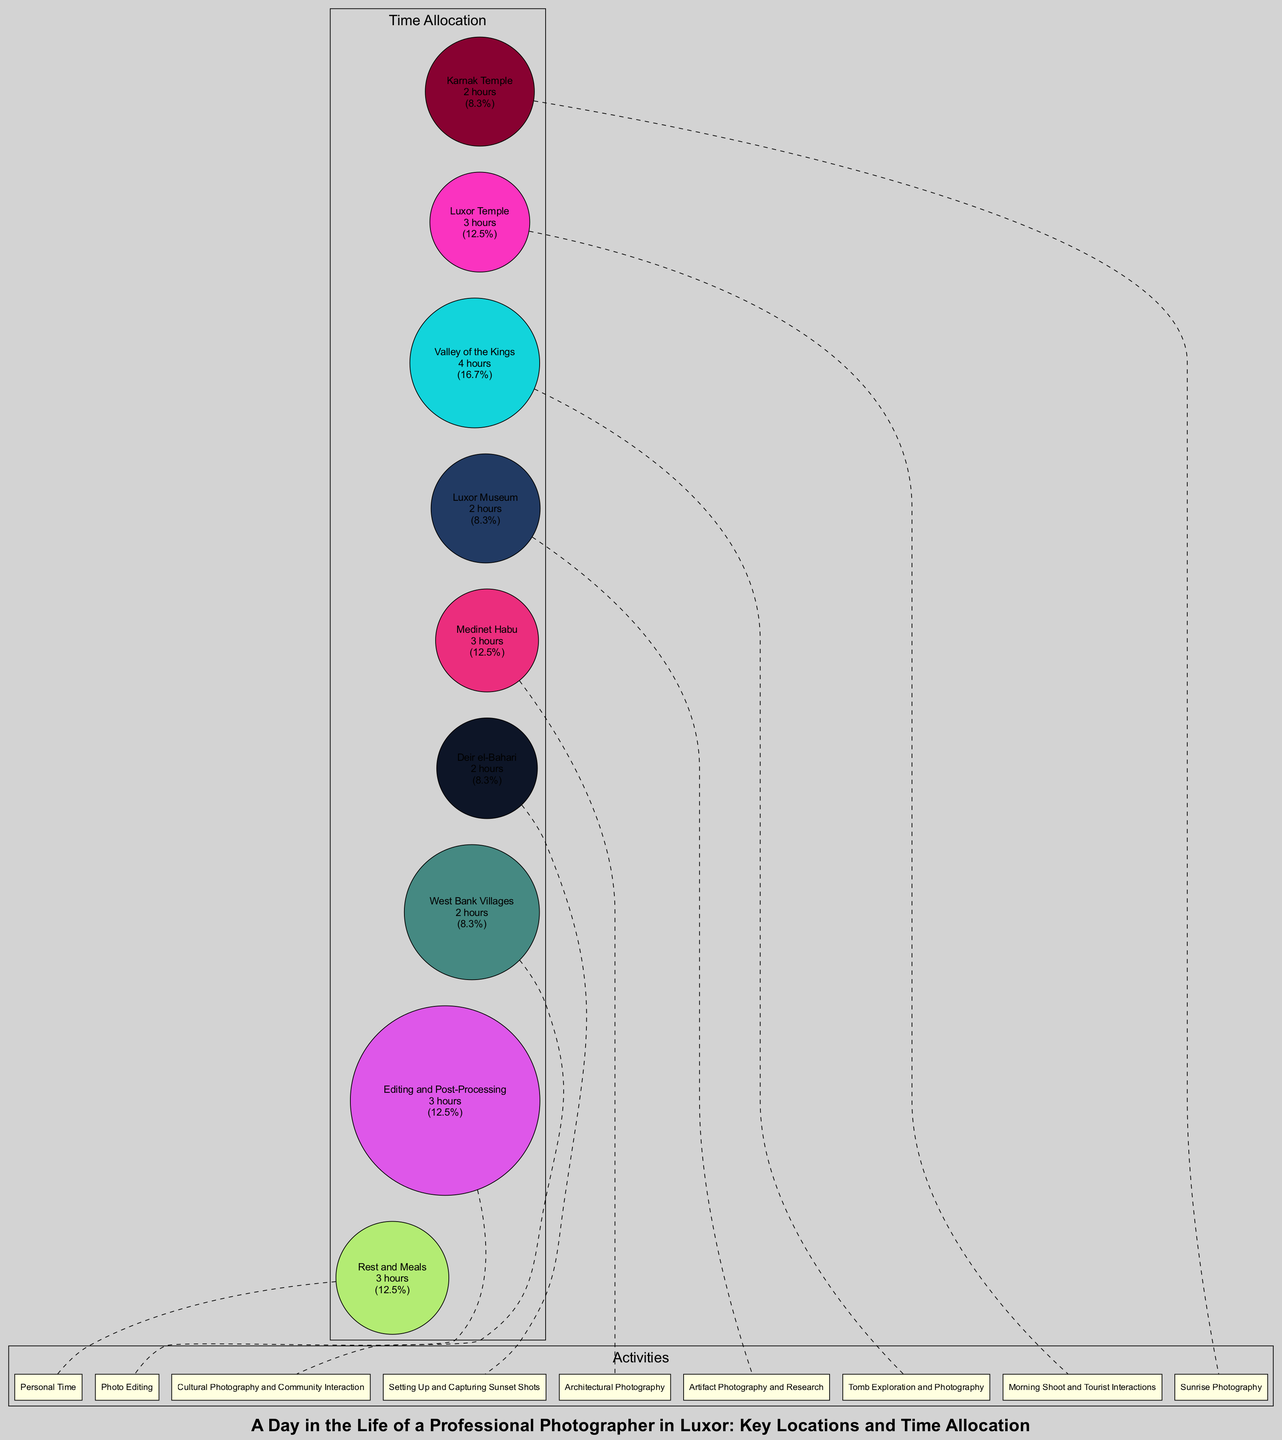What is the total time allocated for photography in Luxor? The diagram outlines time allocations for various activities throughout the day. By summing all the allocated times (2 + 3 + 4 + 2 + 3 + 2 + 2 + 3 + 3), the total time allocated for photography-related activities is determined.
Answer: 24 hours How many hours are allocated for shooting at the Valley of the Kings? The specific time allocated for the Valley of the Kings is called out in the diagram as part of the time allocation for photography. By locating this information, it can be clearly identified that it is allocated 4 hours.
Answer: 4 hours Which location is assigned the most time for photography? The total time allocations for each location are compared, and the one with the highest value is identified, leading to the conclusion that the Valley of the Kings has the most time at 4 hours.
Answer: Valley of the Kings What activity takes place during the time spent at Luxor Temple? Referring to the Luxor Temple section of the diagram, the activity specifically mentioned is "Morning Shoot and Tourist Interactions," which defines the primary focus during the allocated time.
Answer: Morning Shoot and Tourist Interactions How many hours are allocated for personal time, including rest and meals? The diagram explicitly mentions that 3 hours are set aside for "Rest and Meals." This value can be found directly in the section detailing time allocation.
Answer: 3 hours What percentage of the day is spent on editing and post-processing? The time allocated for editing and post-processing is recognized as 3 hours. To find the percentage, this time is divided by the total time (24 hours), yielding 12.5%.
Answer: 12.5% Which activity requires less than 3 hours? The diagram lists the time allocations for each location and activity. By scanning this, it is evident that Karnak Temple, Luxor Museum, Deir el-Bahari, and West Bank Villages are all activities assigned 2 hours, which is less than 3 hours.
Answer: Karnak Temple, Luxor Museum, Deir el-Bahari, West Bank Villages How many locations involve cultural photography? By examining the activities in the diagram, "Cultural Photography and Community Interaction" is identified as the only activity explicitly stated to involve cultural photography, which indicates it is specifically tied to the West Bank Villages location.
Answer: 1 location 